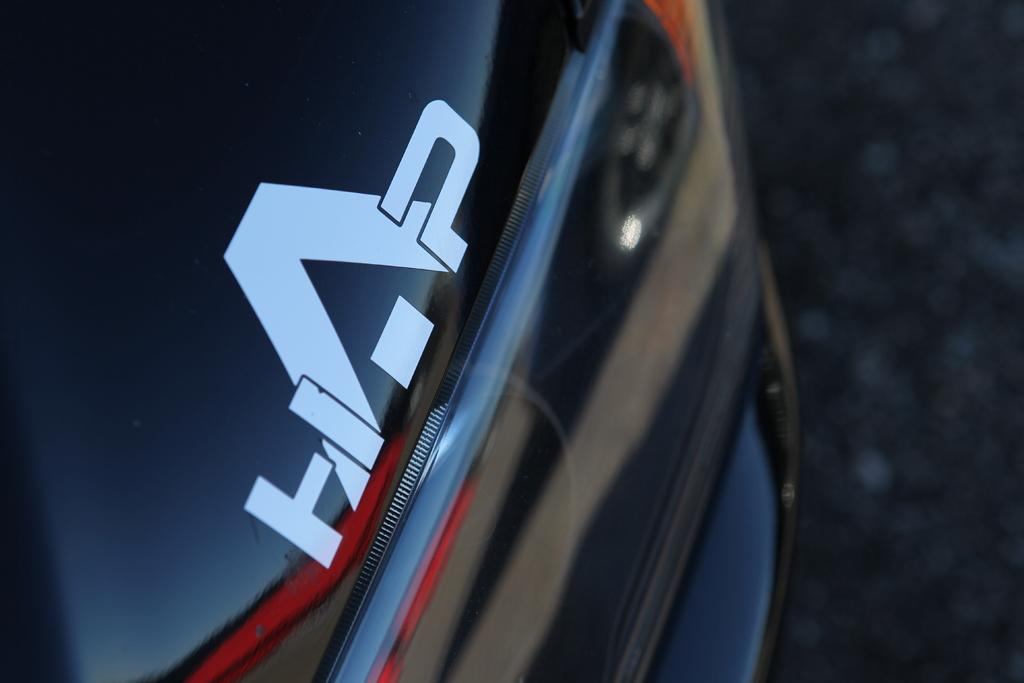What is on the vehicle in the image? There is a sticker on the vehicle in the image. Can you describe the background of the image? The background of the image is blurry. What type of songs can be heard coming from the scarecrow in the image? There is no scarecrow present in the image, so it's not possible to determine what, if any, songs might be heard. 